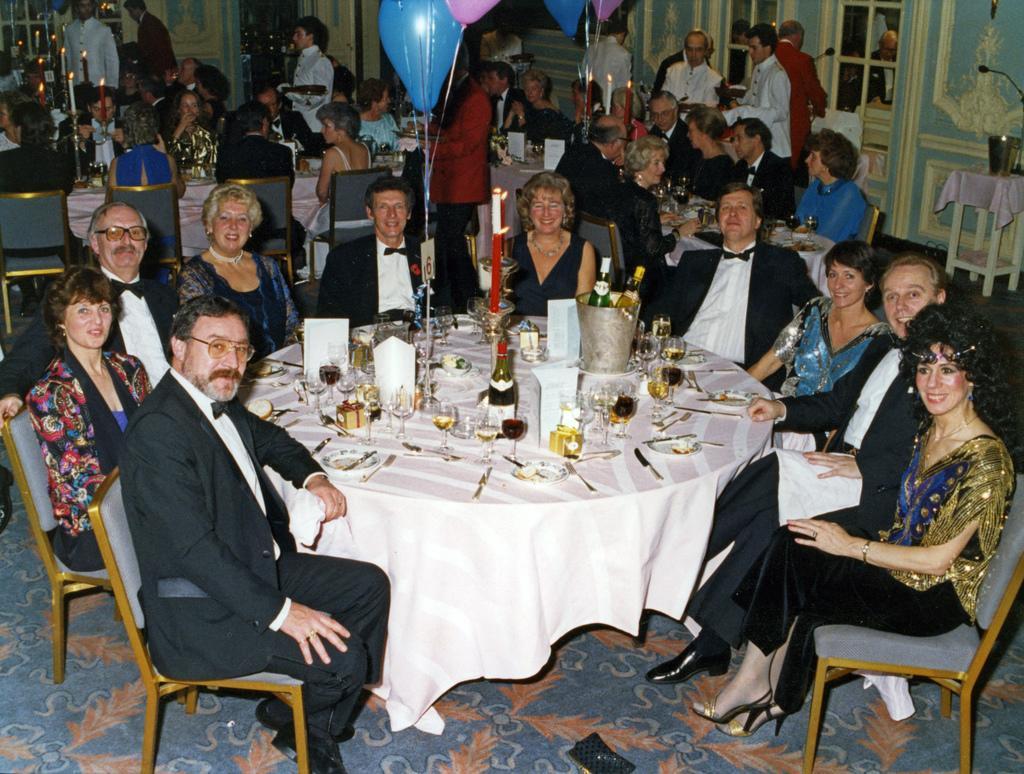In one or two sentences, can you explain what this image depicts? In this image there are group of people sitting and smiling, there are few glasses, bottles, papers on the table, at the back ground i can see a balloon, few people sitting and a wall. 